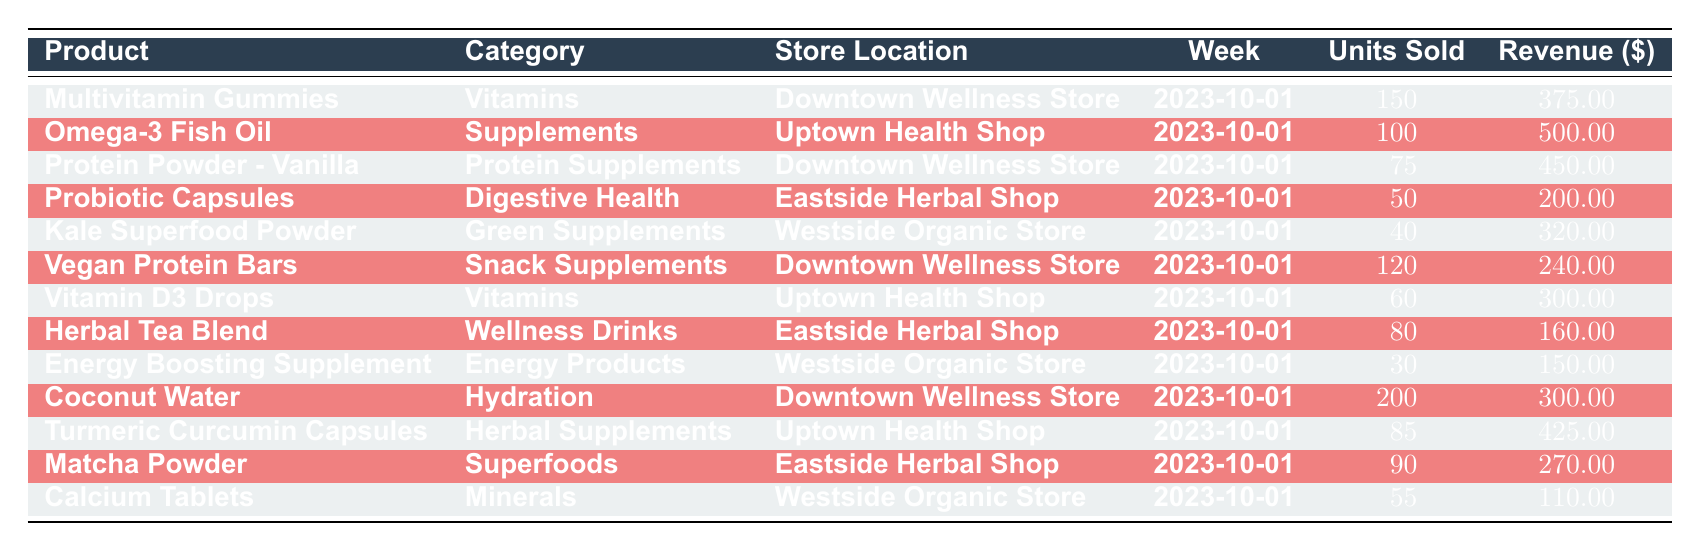What is the highest revenue product in the data? The highest revenue can be identified by checking the revenue column for all products. The product "Omega-3 Fish Oil" has the highest revenue of 500.00
Answer: 500.00 How many units of Coconut Water were sold? Looking at the row for "Coconut Water" under the "Units Sold" column, it shows that 200 units were sold
Answer: 200 Which store had the most sales in terms of units sold? To determine the store with the most sales in units, I will sum the units sold by each store. Downtown Wellness Store: 150 + 75 + 120 + 200 = 545, Uptown Health Shop: 100 + 60 + 85 = 245, Eastside Herbal Shop: 50 + 80 + 90 = 220, Westside Organic Store: 40 + 30 + 55 = 125. The Downtown Wellness Store has the highest total of 545 units sold
Answer: Downtown Wellness Store Is the total revenue from the Eastside Herbal Shop greater than from the Uptown Health Shop? Calculate the total revenue for Eastside Herbal Shop: 200 (Probiotic Capsules) + 160 (Herbal Tea Blend) + 270 (Matcha Powder) = 630. For Uptown Health Shop: 500 (Omega-3 Fish Oil) + 300 (Vitamin D3 Drops) + 425 (Turmeric Curcumin Capsules) = 1225. Since 630 is not greater than 1225, the statement is false
Answer: No What is the average revenue of all health supplements sold? To find the average revenue, sum the total revenue of all products. The total revenue is 375 + 500 + 450 + 200 + 320 + 240 + 300 + 160 + 150 + 300 + 425 + 270 + 110 = 3200, and there are 13 products, so the average revenue is 3200 / 13 = 246.15
Answer: 246.15 Which product sold the least number of units? By reviewing the "Units Sold" column, the product "Energy Boosting Supplement" has the least units at 30
Answer: 30 Are there any products with a revenue of over 400? I will check the revenue column for each product. The products with revenue over 400 are: "Omega-3 Fish Oil", "Protein Powder - Vanilla", "Turmeric Curcumin Capsules". Therefore, there are products that fit this criterion
Answer: Yes How much more revenue did the Uptown Health Shop generate compared to the Eastside Herbal Shop? Calculate the total revenue for each shop: Uptown Health Shop: 500 + 300 + 425 = 1225, Eastside Herbal Shop: 200 + 160 + 270 = 630. The difference is 1225 - 630 = 595, so the Uptown Health Shop generated 595 more
Answer: 595 